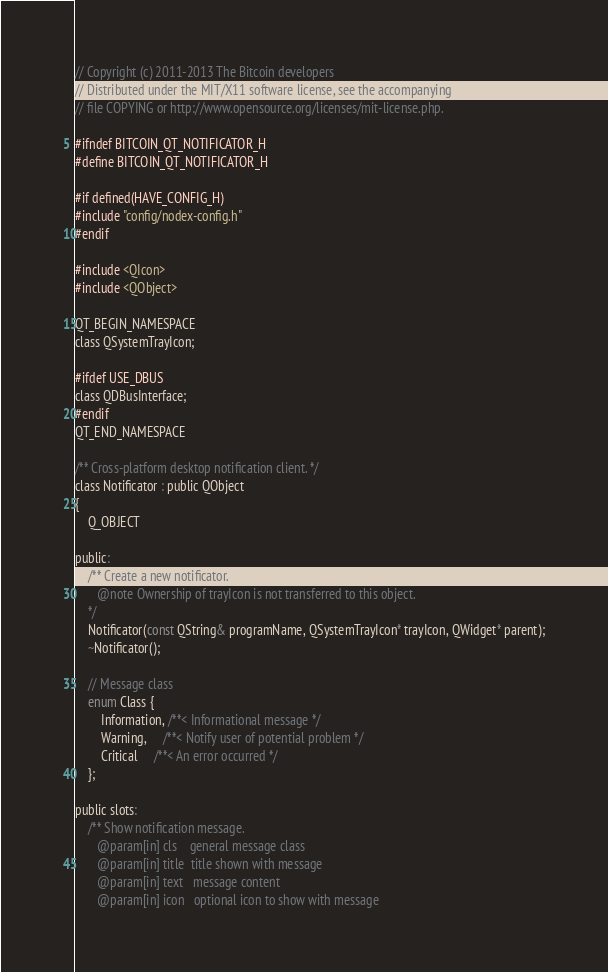Convert code to text. <code><loc_0><loc_0><loc_500><loc_500><_C_>// Copyright (c) 2011-2013 The Bitcoin developers
// Distributed under the MIT/X11 software license, see the accompanying
// file COPYING or http://www.opensource.org/licenses/mit-license.php.

#ifndef BITCOIN_QT_NOTIFICATOR_H
#define BITCOIN_QT_NOTIFICATOR_H

#if defined(HAVE_CONFIG_H)
#include "config/nodex-config.h"
#endif

#include <QIcon>
#include <QObject>

QT_BEGIN_NAMESPACE
class QSystemTrayIcon;

#ifdef USE_DBUS
class QDBusInterface;
#endif
QT_END_NAMESPACE

/** Cross-platform desktop notification client. */
class Notificator : public QObject
{
    Q_OBJECT

public:
    /** Create a new notificator.
       @note Ownership of trayIcon is not transferred to this object.
    */
    Notificator(const QString& programName, QSystemTrayIcon* trayIcon, QWidget* parent);
    ~Notificator();

    // Message class
    enum Class {
        Information, /**< Informational message */
        Warning,     /**< Notify user of potential problem */
        Critical     /**< An error occurred */
    };

public slots:
    /** Show notification message.
       @param[in] cls    general message class
       @param[in] title  title shown with message
       @param[in] text   message content
       @param[in] icon   optional icon to show with message</code> 